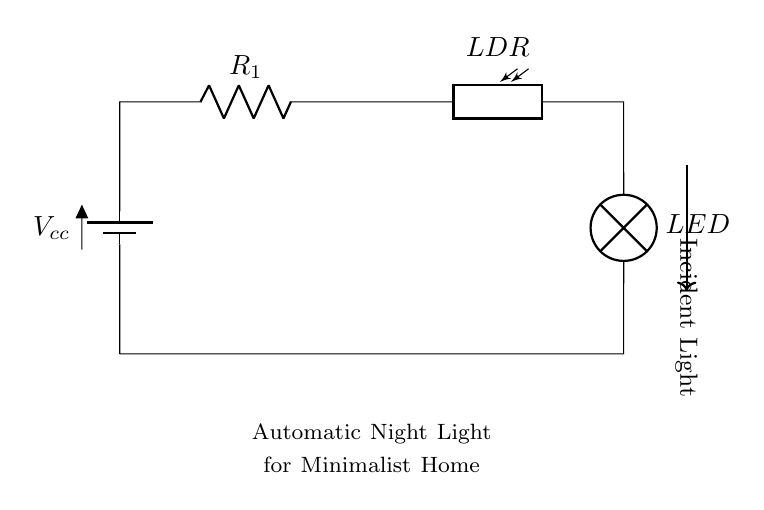What type of components are used in this circuit? The circuit consists of a battery, a resistor, a photoresistor, and an LED, which are the basic components needed for the automatic night light function.
Answer: battery, resistor, photoresistor, LED What is the role of the photoresistor in this circuit? The photoresistor detects the level of ambient light; it changes its resistance based on the intensity of the light, which allows the LED to turn on or off automatically.
Answer: light sensor How many resistors are present in the circuit? There is one resistor shown in the circuit diagram, labeled as R1.
Answer: one What happens to the LED when it is dark? When it is dark, the photoresistor has high resistance, allowing current to flow through the circuit and turning the LED on.
Answer: LED turns on What effect does increasing the incident light have on the circuit? Increasing the incident light reduces the resistance of the photoresistor, which decreases the current through the circuit, causing the LED to turn off.
Answer: LED turns off What is the purpose of the resistor in series with the photoresistor? The resistor is used to limit the current flowing through the circuit to protect the LED from excessive current and ensure proper operation of the components.
Answer: current limiting What kind of circuit is represented in this diagram? The circuit is a series circuit, where components are connected one after another, providing a single path for current flow.
Answer: series circuit 